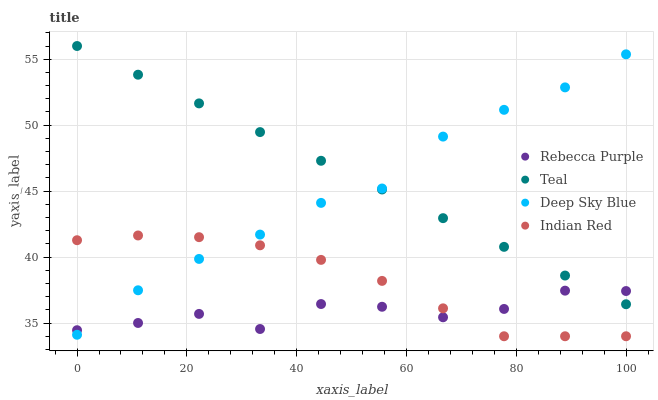Does Rebecca Purple have the minimum area under the curve?
Answer yes or no. Yes. Does Teal have the maximum area under the curve?
Answer yes or no. Yes. Does Deep Sky Blue have the minimum area under the curve?
Answer yes or no. No. Does Deep Sky Blue have the maximum area under the curve?
Answer yes or no. No. Is Teal the smoothest?
Answer yes or no. Yes. Is Rebecca Purple the roughest?
Answer yes or no. Yes. Is Deep Sky Blue the smoothest?
Answer yes or no. No. Is Deep Sky Blue the roughest?
Answer yes or no. No. Does Indian Red have the lowest value?
Answer yes or no. Yes. Does Deep Sky Blue have the lowest value?
Answer yes or no. No. Does Teal have the highest value?
Answer yes or no. Yes. Does Deep Sky Blue have the highest value?
Answer yes or no. No. Is Indian Red less than Teal?
Answer yes or no. Yes. Is Teal greater than Indian Red?
Answer yes or no. Yes. Does Teal intersect Rebecca Purple?
Answer yes or no. Yes. Is Teal less than Rebecca Purple?
Answer yes or no. No. Is Teal greater than Rebecca Purple?
Answer yes or no. No. Does Indian Red intersect Teal?
Answer yes or no. No. 